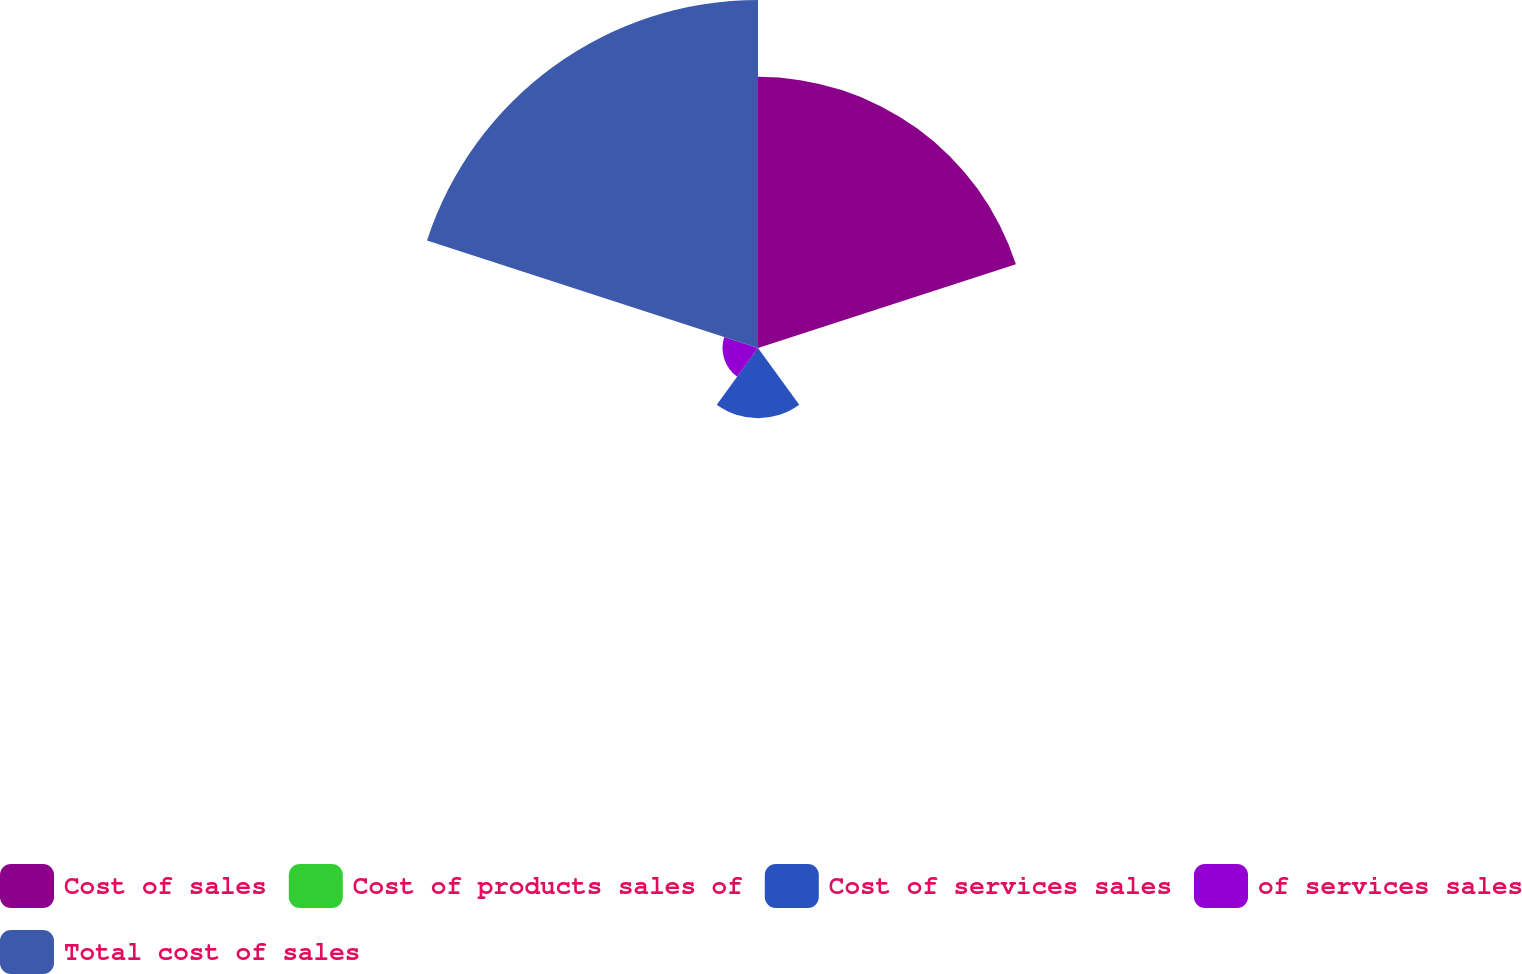<chart> <loc_0><loc_0><loc_500><loc_500><pie_chart><fcel>Cost of sales<fcel>Cost of products sales of<fcel>Cost of services sales<fcel>of services sales<fcel>Total cost of sales<nl><fcel>37.38%<fcel>0.1%<fcel>9.67%<fcel>4.89%<fcel>47.97%<nl></chart> 